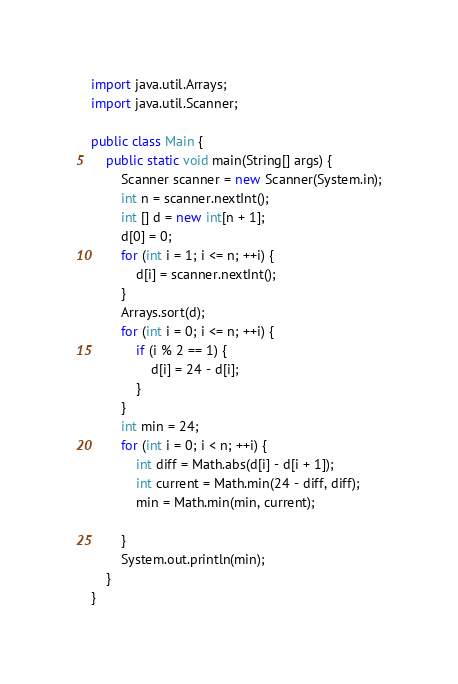Convert code to text. <code><loc_0><loc_0><loc_500><loc_500><_Java_>
import java.util.Arrays;
import java.util.Scanner;

public class Main {
    public static void main(String[] args) {
        Scanner scanner = new Scanner(System.in);
        int n = scanner.nextInt();
        int [] d = new int[n + 1];
        d[0] = 0;
        for (int i = 1; i <= n; ++i) {
            d[i] = scanner.nextInt();
        }
        Arrays.sort(d);
        for (int i = 0; i <= n; ++i) {
            if (i % 2 == 1) {
                d[i] = 24 - d[i];
            }
        }
        int min = 24;
        for (int i = 0; i < n; ++i) {
            int diff = Math.abs(d[i] - d[i + 1]);
            int current = Math.min(24 - diff, diff);
            min = Math.min(min, current);

        }
        System.out.println(min);
    }
}
</code> 